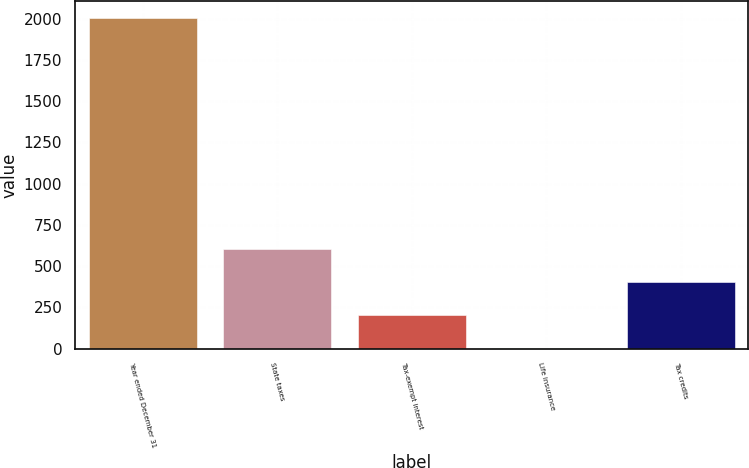<chart> <loc_0><loc_0><loc_500><loc_500><bar_chart><fcel>Year ended December 31<fcel>State taxes<fcel>Tax-exempt interest<fcel>Life insurance<fcel>Tax credits<nl><fcel>2005<fcel>602.2<fcel>201.4<fcel>1<fcel>401.8<nl></chart> 